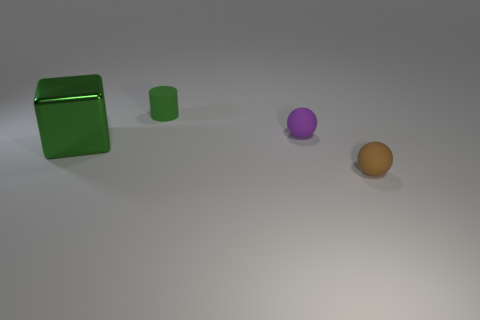Is there a tiny sphere behind the green thing that is in front of the green thing on the right side of the big block?
Give a very brief answer. Yes. There is a matte thing that is in front of the big shiny cube; is its color the same as the small sphere behind the small brown matte ball?
Keep it short and to the point. No. There is a brown thing that is the same size as the green matte cylinder; what material is it?
Your answer should be very brief. Rubber. There is a matte ball that is behind the tiny rubber sphere that is in front of the tiny sphere to the left of the tiny brown matte ball; how big is it?
Keep it short and to the point. Small. How many other things are made of the same material as the brown sphere?
Offer a terse response. 2. What is the size of the rubber thing in front of the big block?
Offer a terse response. Small. What number of objects are right of the big metal thing and behind the brown matte sphere?
Ensure brevity in your answer.  2. There is a large cube on the left side of the small object in front of the large shiny block; what is its material?
Your answer should be compact. Metal. There is a brown thing that is the same shape as the purple rubber thing; what is its material?
Offer a very short reply. Rubber. Is there a large red shiny cube?
Provide a short and direct response. No. 